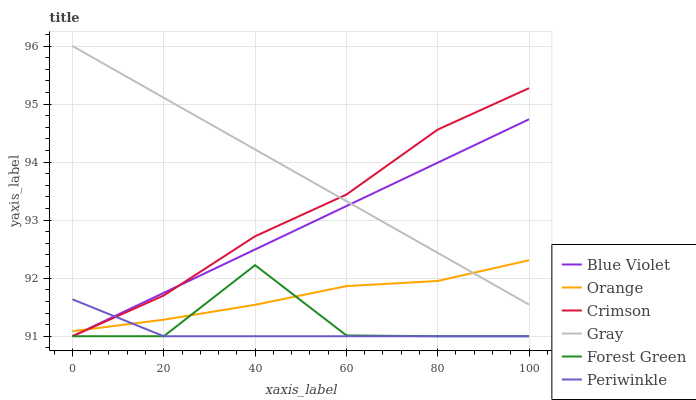Does Periwinkle have the minimum area under the curve?
Answer yes or no. Yes. Does Gray have the maximum area under the curve?
Answer yes or no. Yes. Does Crimson have the minimum area under the curve?
Answer yes or no. No. Does Crimson have the maximum area under the curve?
Answer yes or no. No. Is Blue Violet the smoothest?
Answer yes or no. Yes. Is Forest Green the roughest?
Answer yes or no. Yes. Is Crimson the smoothest?
Answer yes or no. No. Is Crimson the roughest?
Answer yes or no. No. Does Crimson have the lowest value?
Answer yes or no. Yes. Does Orange have the lowest value?
Answer yes or no. No. Does Gray have the highest value?
Answer yes or no. Yes. Does Crimson have the highest value?
Answer yes or no. No. Is Forest Green less than Gray?
Answer yes or no. Yes. Is Gray greater than Forest Green?
Answer yes or no. Yes. Does Gray intersect Crimson?
Answer yes or no. Yes. Is Gray less than Crimson?
Answer yes or no. No. Is Gray greater than Crimson?
Answer yes or no. No. Does Forest Green intersect Gray?
Answer yes or no. No. 